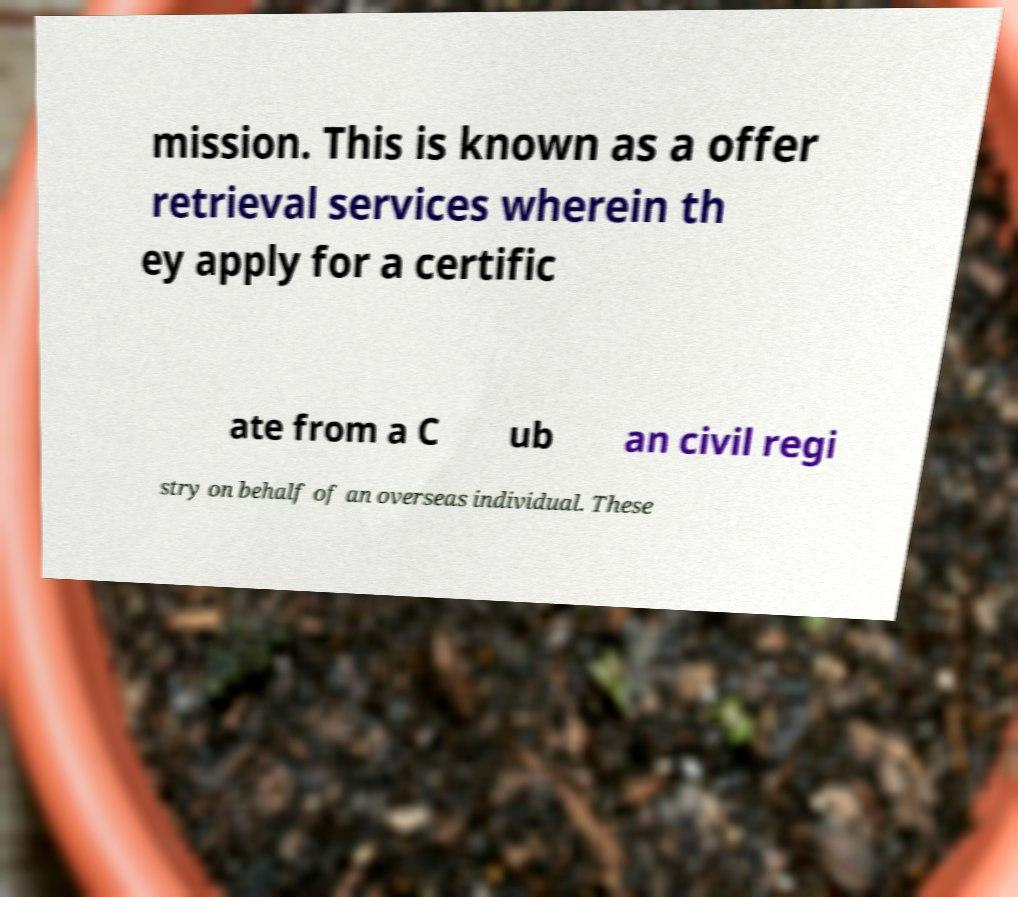Can you accurately transcribe the text from the provided image for me? mission. This is known as a offer retrieval services wherein th ey apply for a certific ate from a C ub an civil regi stry on behalf of an overseas individual. These 